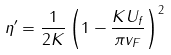Convert formula to latex. <formula><loc_0><loc_0><loc_500><loc_500>\eta ^ { \prime } = \frac { 1 } { 2 K } \left ( 1 - \frac { K U _ { f } } { \pi v _ { F } } \right ) ^ { 2 }</formula> 